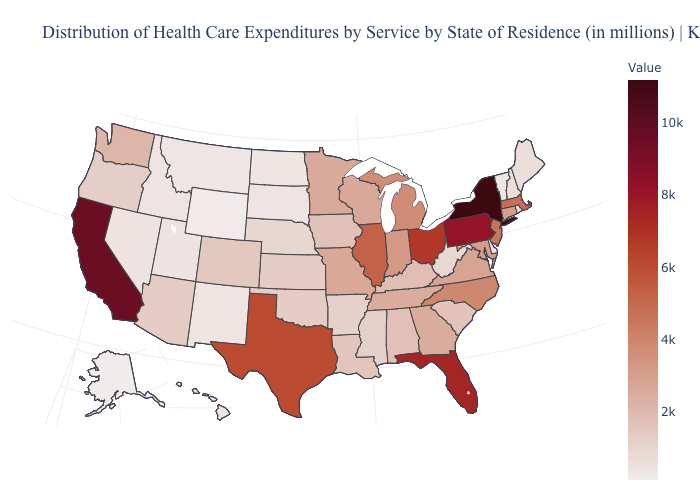Does the map have missing data?
Short answer required. No. Does Iowa have a lower value than Montana?
Short answer required. No. Does Florida have the highest value in the South?
Answer briefly. Yes. Among the states that border Georgia , which have the lowest value?
Answer briefly. South Carolina. Among the states that border Maryland , which have the highest value?
Write a very short answer. Pennsylvania. Among the states that border Pennsylvania , which have the lowest value?
Write a very short answer. Delaware. Which states have the lowest value in the USA?
Be succinct. Alaska. 